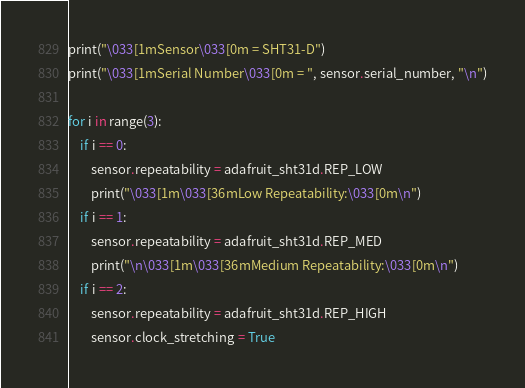Convert code to text. <code><loc_0><loc_0><loc_500><loc_500><_Python_>print("\033[1mSensor\033[0m = SHT31-D")
print("\033[1mSerial Number\033[0m = ", sensor.serial_number, "\n")

for i in range(3):
    if i == 0:
        sensor.repeatability = adafruit_sht31d.REP_LOW
        print("\033[1m\033[36mLow Repeatability:\033[0m\n")
    if i == 1:
        sensor.repeatability = adafruit_sht31d.REP_MED
        print("\n\033[1m\033[36mMedium Repeatability:\033[0m\n")
    if i == 2:
        sensor.repeatability = adafruit_sht31d.REP_HIGH
        sensor.clock_stretching = True</code> 